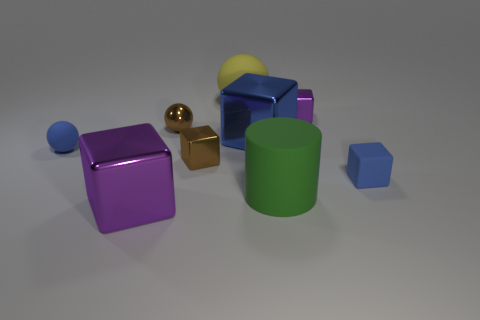Subtract all blue cylinders. How many purple cubes are left? 2 Subtract all tiny blue blocks. How many blocks are left? 4 Subtract all purple blocks. How many blocks are left? 3 Subtract 1 blocks. How many blocks are left? 4 Subtract all blocks. How many objects are left? 4 Subtract all green blocks. Subtract all green balls. How many blocks are left? 5 Subtract 0 red spheres. How many objects are left? 9 Subtract all large yellow shiny blocks. Subtract all purple things. How many objects are left? 7 Add 3 brown blocks. How many brown blocks are left? 4 Add 9 small purple blocks. How many small purple blocks exist? 10 